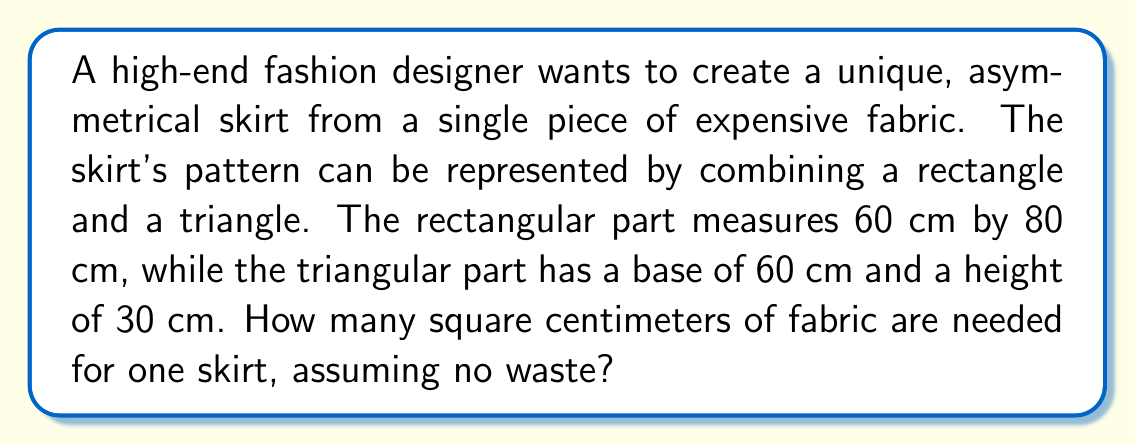Solve this math problem. Let's approach this step-by-step:

1. Calculate the area of the rectangular part:
   $$A_{rectangle} = length \times width$$
   $$A_{rectangle} = 60 \text{ cm} \times 80 \text{ cm} = 4800 \text{ cm}^2$$

2. Calculate the area of the triangular part:
   $$A_{triangle} = \frac{1}{2} \times base \times height$$
   $$A_{triangle} = \frac{1}{2} \times 60 \text{ cm} \times 30 \text{ cm} = 900 \text{ cm}^2$$

3. Sum up the areas to get the total fabric needed:
   $$A_{total} = A_{rectangle} + A_{triangle}$$
   $$A_{total} = 4800 \text{ cm}^2 + 900 \text{ cm}^2 = 5700 \text{ cm}^2$$

[asy]
size(200);
fill((0,0)--(60,0)--(60,80)--(0,80)--cycle,lightgray);
fill((60,0)--(120,0)--(60,30)--cycle,lightgray);
draw((0,0)--(120,0)--(60,30)--(60,80)--(0,80)--cycle);
label("80 cm", (65,40), E);
label("60 cm", (30,0), S);
label("60 cm", (90,0), S);
label("30 cm", (90,15), E);
[/asy]

Therefore, 5700 square centimeters of fabric are needed for one skirt.
Answer: 5700 cm² 